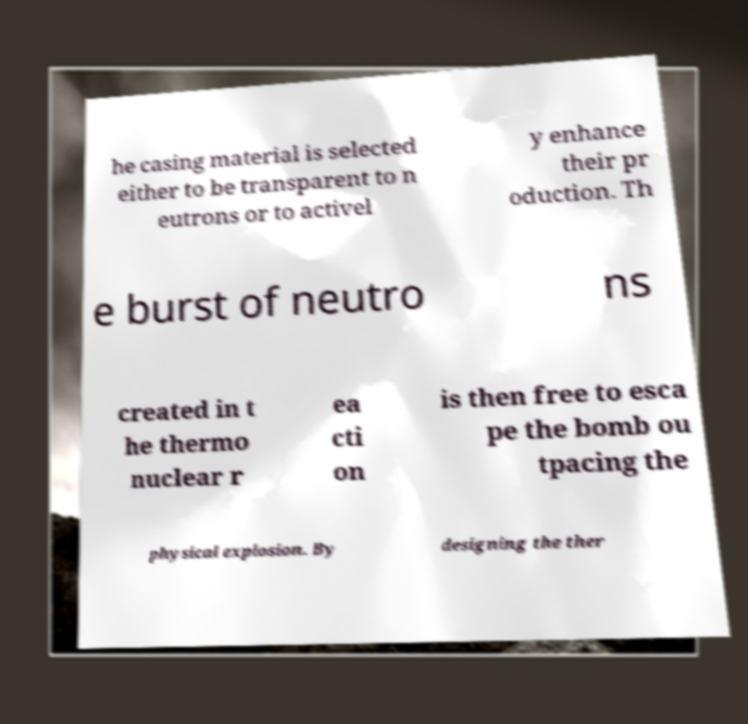Can you accurately transcribe the text from the provided image for me? he casing material is selected either to be transparent to n eutrons or to activel y enhance their pr oduction. Th e burst of neutro ns created in t he thermo nuclear r ea cti on is then free to esca pe the bomb ou tpacing the physical explosion. By designing the ther 